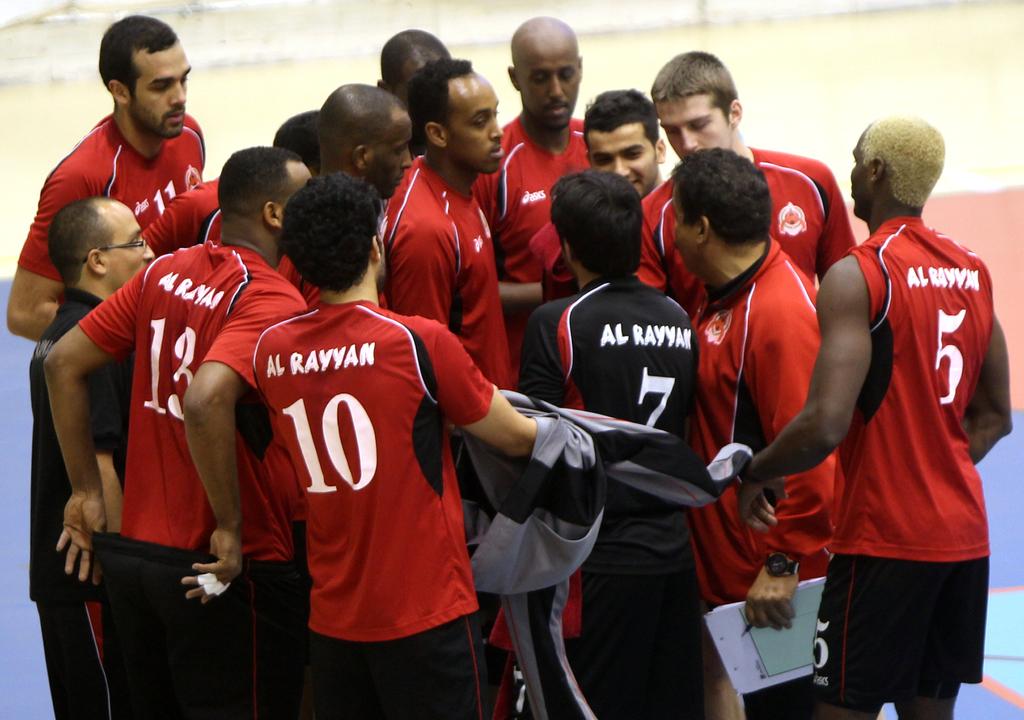What is the name of the school these men are playing for?
Give a very brief answer. Al rayyan. What is the player in blacks jersey number?
Ensure brevity in your answer.  7. 